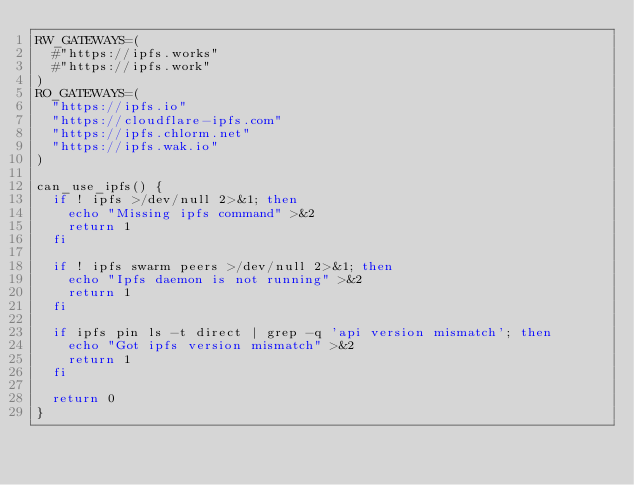Convert code to text. <code><loc_0><loc_0><loc_500><loc_500><_Bash_>RW_GATEWAYS=(
  #"https://ipfs.works"
  #"https://ipfs.work"
)
RO_GATEWAYS=(
  "https://ipfs.io"
  "https://cloudflare-ipfs.com"
  "https://ipfs.chlorm.net"
  "https://ipfs.wak.io"
)

can_use_ipfs() {
  if ! ipfs >/dev/null 2>&1; then
    echo "Missing ipfs command" >&2
    return 1
  fi

  if ! ipfs swarm peers >/dev/null 2>&1; then
    echo "Ipfs daemon is not running" >&2
    return 1
  fi

  if ipfs pin ls -t direct | grep -q 'api version mismatch'; then
    echo "Got ipfs version mismatch" >&2
    return 1
  fi

  return 0
}

</code> 